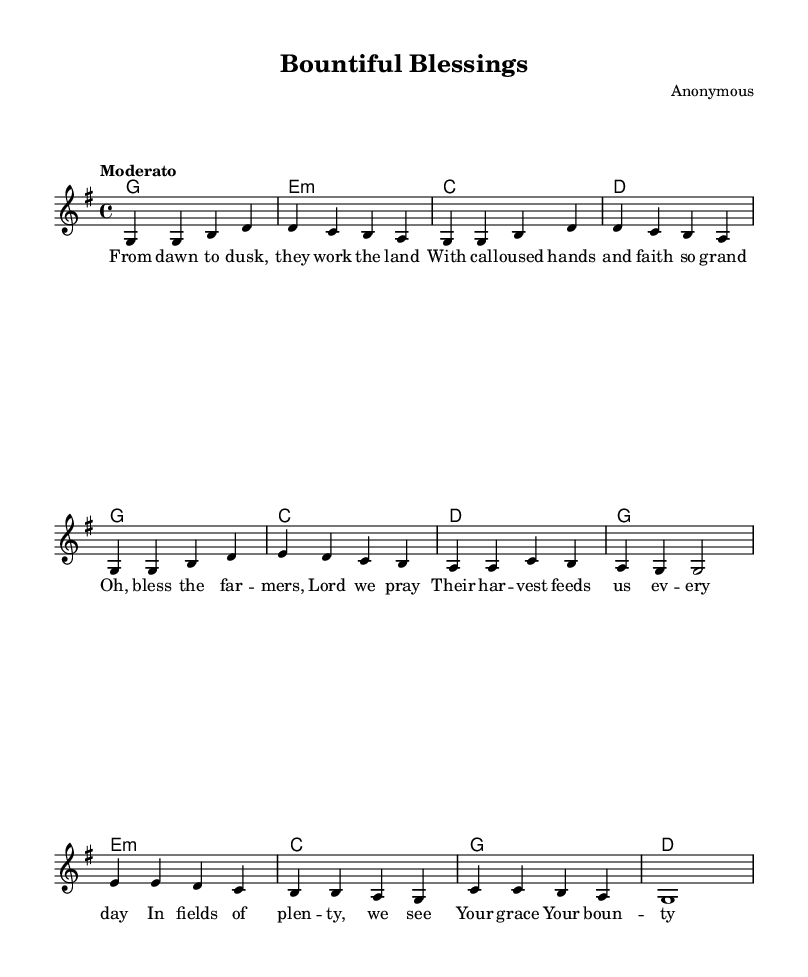What is the key signature of this music? The key signature is G major, which has one sharp (F#).
Answer: G major What is the time signature of this music? The time signature is 4/4, indicating four beats per measure.
Answer: 4/4 What is the tempo marking for this piece? The tempo marking is "Moderato," which suggests a moderate pace.
Answer: Moderato How many measures are in the chorus section? The chorus consists of four measures, as indicated by the grouping of the notes.
Answer: 4 What is the main theme expressed in the lyrics? The lyrics focus on praising farmers for their hard work and the blessings that come from their labor.
Answer: Praising farmers What is the musical section that follows the verse? The section following the verse is the chorus, as it is structured to repeat after the verse.
Answer: Chorus What is the significance of the bridge in this song? The bridge introduces a reflective theme about God's grace and abundance, providing a contrast to the verses and chorus.
Answer: Reflection on grace 